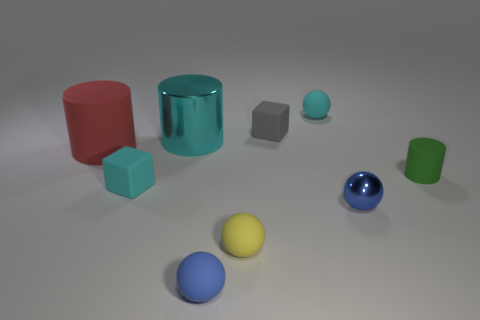There is a small cyan rubber object in front of the ball behind the red cylinder; what number of gray blocks are to the right of it?
Your answer should be very brief. 1. The yellow object that is made of the same material as the tiny green object is what shape?
Keep it short and to the point. Sphere. There is a thing that is behind the tiny cube to the right of the tiny block to the left of the shiny cylinder; what is it made of?
Provide a short and direct response. Rubber. How many objects are either tiny blue spheres on the left side of the blue shiny ball or gray cubes?
Provide a short and direct response. 2. How many other objects are the same shape as the large matte object?
Ensure brevity in your answer.  2. Is the number of large cyan objects that are left of the cyan metallic thing greater than the number of rubber cylinders?
Your response must be concise. No. What size is the other thing that is the same shape as the tiny gray rubber object?
Give a very brief answer. Small. What is the shape of the red rubber thing?
Provide a short and direct response. Cylinder. What is the shape of the blue matte thing that is the same size as the green object?
Your answer should be very brief. Sphere. Are there any other things that have the same color as the tiny metallic object?
Ensure brevity in your answer.  Yes. 